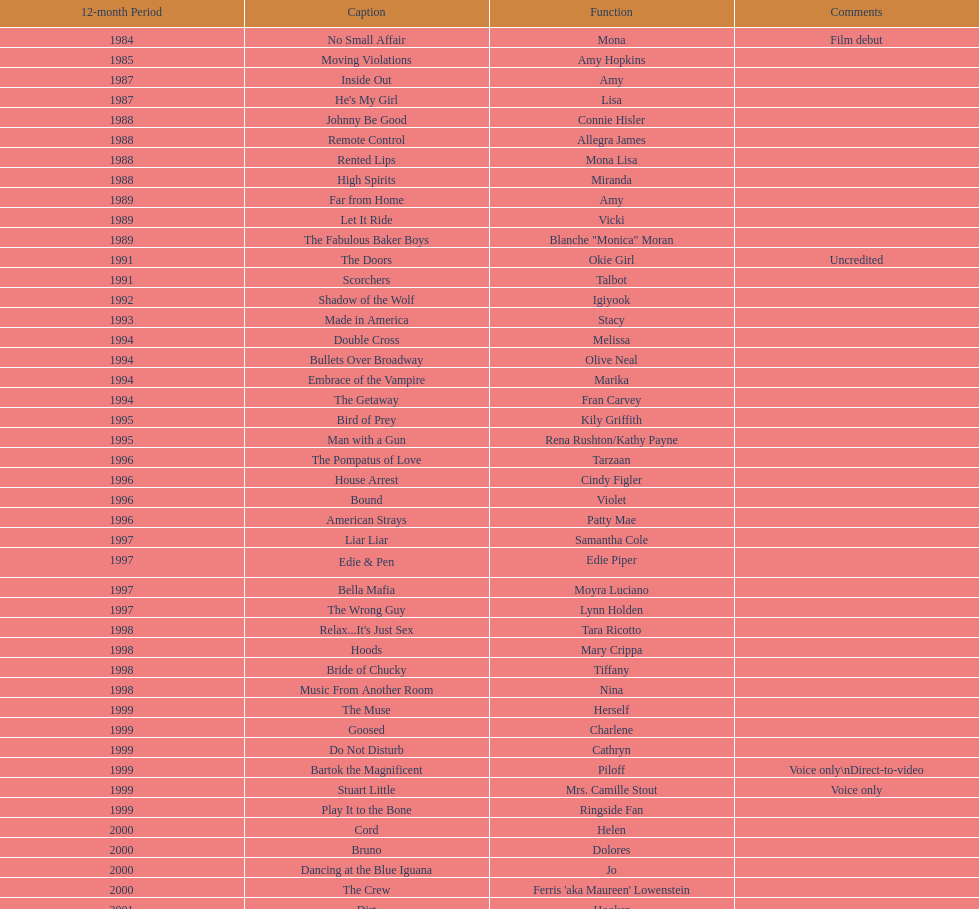Which movie was also a film debut? No Small Affair. 